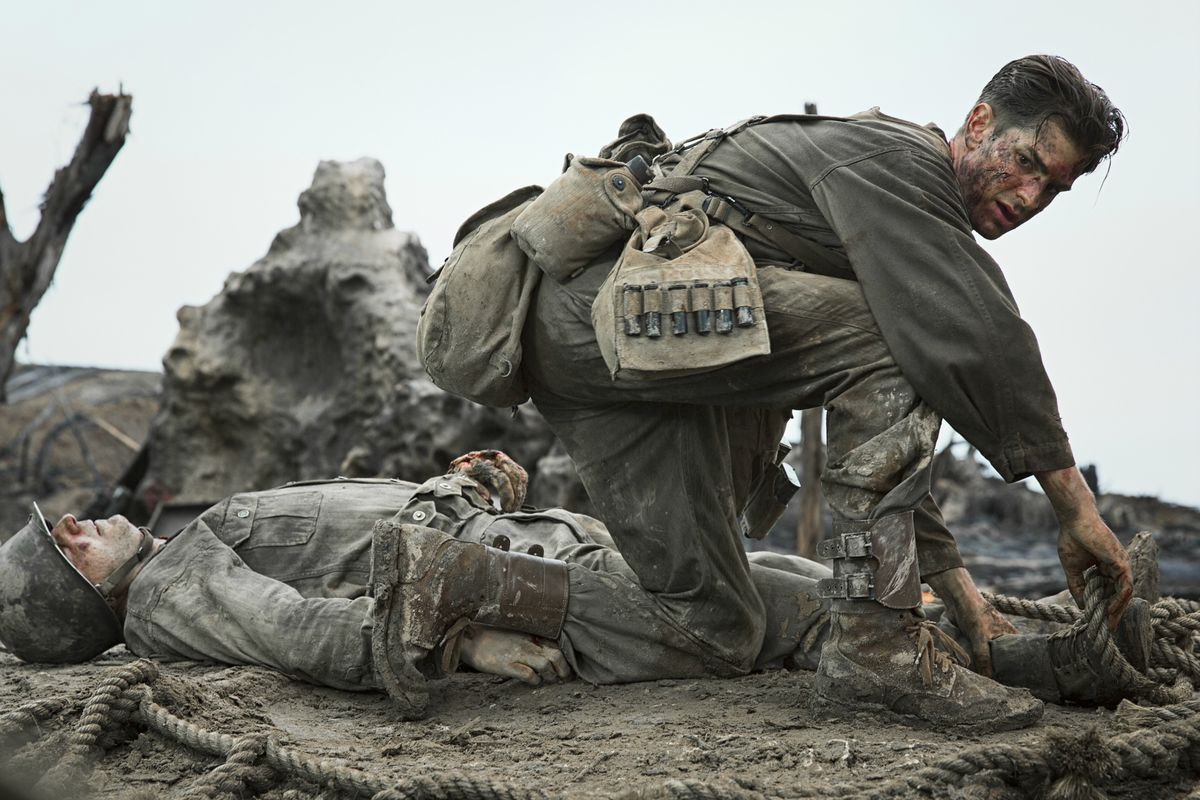What emotions do you think Andrew Garfield's character is experiencing in this moment? In this moment, Andrew Garfield's character, Desmond Doss, is likely experiencing a whirlwind of intense emotions. He appears deeply focused and determined, committed to his role as a medic despite the chaos around him. There's an evident strain of urgency and concern for the lives of the wounded soldiers he is trying to save. Amidst these emotions, one can also sense a somber reflection of the grim reality of war, mixed with compassion and an unwavering sense of duty. 